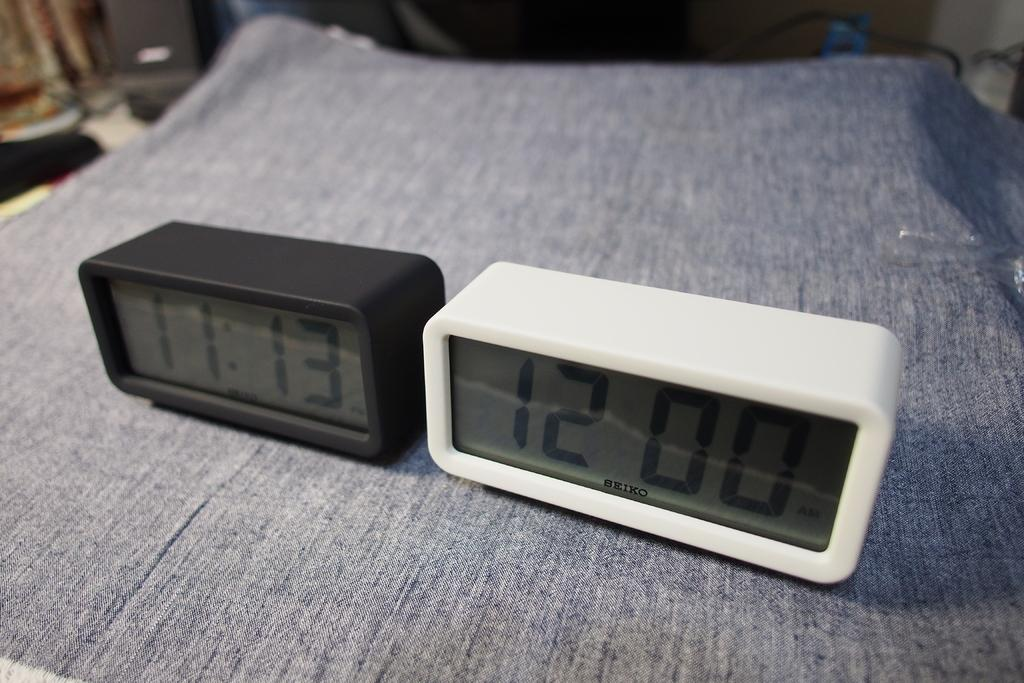<image>
Relay a brief, clear account of the picture shown. Two Seiko digital clocks sit side by side showing different times. 